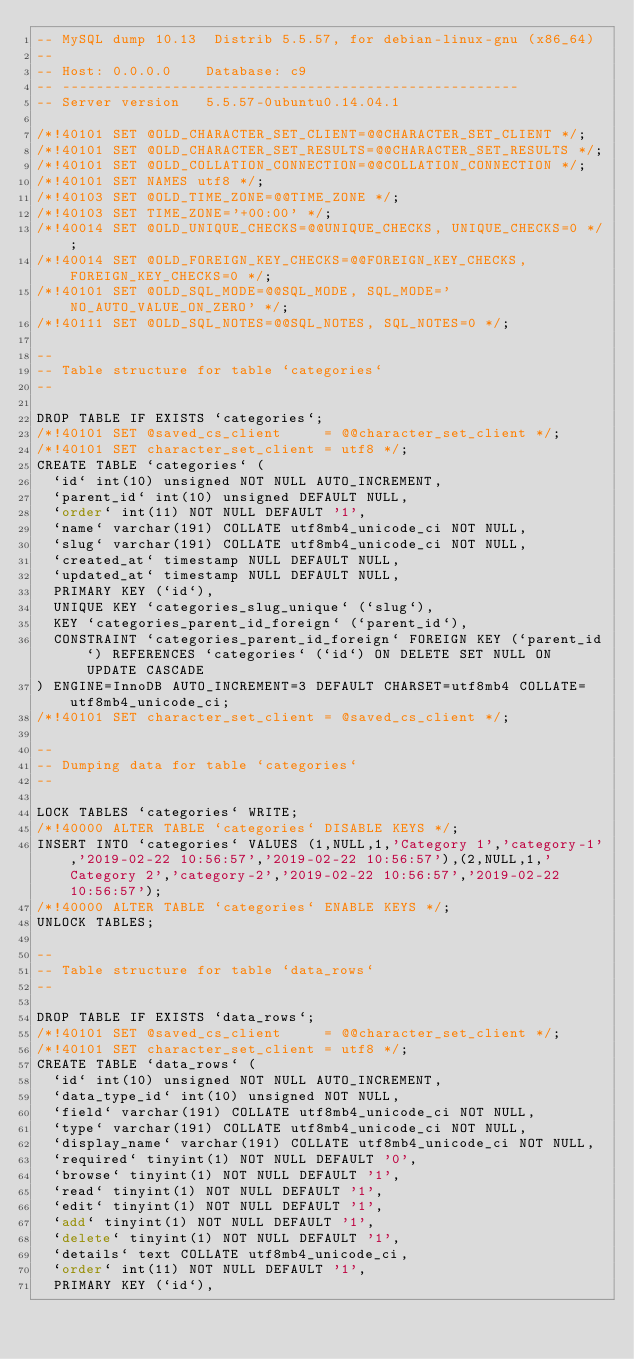Convert code to text. <code><loc_0><loc_0><loc_500><loc_500><_SQL_>-- MySQL dump 10.13  Distrib 5.5.57, for debian-linux-gnu (x86_64)
--
-- Host: 0.0.0.0    Database: c9
-- ------------------------------------------------------
-- Server version	5.5.57-0ubuntu0.14.04.1

/*!40101 SET @OLD_CHARACTER_SET_CLIENT=@@CHARACTER_SET_CLIENT */;
/*!40101 SET @OLD_CHARACTER_SET_RESULTS=@@CHARACTER_SET_RESULTS */;
/*!40101 SET @OLD_COLLATION_CONNECTION=@@COLLATION_CONNECTION */;
/*!40101 SET NAMES utf8 */;
/*!40103 SET @OLD_TIME_ZONE=@@TIME_ZONE */;
/*!40103 SET TIME_ZONE='+00:00' */;
/*!40014 SET @OLD_UNIQUE_CHECKS=@@UNIQUE_CHECKS, UNIQUE_CHECKS=0 */;
/*!40014 SET @OLD_FOREIGN_KEY_CHECKS=@@FOREIGN_KEY_CHECKS, FOREIGN_KEY_CHECKS=0 */;
/*!40101 SET @OLD_SQL_MODE=@@SQL_MODE, SQL_MODE='NO_AUTO_VALUE_ON_ZERO' */;
/*!40111 SET @OLD_SQL_NOTES=@@SQL_NOTES, SQL_NOTES=0 */;

--
-- Table structure for table `categories`
--

DROP TABLE IF EXISTS `categories`;
/*!40101 SET @saved_cs_client     = @@character_set_client */;
/*!40101 SET character_set_client = utf8 */;
CREATE TABLE `categories` (
  `id` int(10) unsigned NOT NULL AUTO_INCREMENT,
  `parent_id` int(10) unsigned DEFAULT NULL,
  `order` int(11) NOT NULL DEFAULT '1',
  `name` varchar(191) COLLATE utf8mb4_unicode_ci NOT NULL,
  `slug` varchar(191) COLLATE utf8mb4_unicode_ci NOT NULL,
  `created_at` timestamp NULL DEFAULT NULL,
  `updated_at` timestamp NULL DEFAULT NULL,
  PRIMARY KEY (`id`),
  UNIQUE KEY `categories_slug_unique` (`slug`),
  KEY `categories_parent_id_foreign` (`parent_id`),
  CONSTRAINT `categories_parent_id_foreign` FOREIGN KEY (`parent_id`) REFERENCES `categories` (`id`) ON DELETE SET NULL ON UPDATE CASCADE
) ENGINE=InnoDB AUTO_INCREMENT=3 DEFAULT CHARSET=utf8mb4 COLLATE=utf8mb4_unicode_ci;
/*!40101 SET character_set_client = @saved_cs_client */;

--
-- Dumping data for table `categories`
--

LOCK TABLES `categories` WRITE;
/*!40000 ALTER TABLE `categories` DISABLE KEYS */;
INSERT INTO `categories` VALUES (1,NULL,1,'Category 1','category-1','2019-02-22 10:56:57','2019-02-22 10:56:57'),(2,NULL,1,'Category 2','category-2','2019-02-22 10:56:57','2019-02-22 10:56:57');
/*!40000 ALTER TABLE `categories` ENABLE KEYS */;
UNLOCK TABLES;

--
-- Table structure for table `data_rows`
--

DROP TABLE IF EXISTS `data_rows`;
/*!40101 SET @saved_cs_client     = @@character_set_client */;
/*!40101 SET character_set_client = utf8 */;
CREATE TABLE `data_rows` (
  `id` int(10) unsigned NOT NULL AUTO_INCREMENT,
  `data_type_id` int(10) unsigned NOT NULL,
  `field` varchar(191) COLLATE utf8mb4_unicode_ci NOT NULL,
  `type` varchar(191) COLLATE utf8mb4_unicode_ci NOT NULL,
  `display_name` varchar(191) COLLATE utf8mb4_unicode_ci NOT NULL,
  `required` tinyint(1) NOT NULL DEFAULT '0',
  `browse` tinyint(1) NOT NULL DEFAULT '1',
  `read` tinyint(1) NOT NULL DEFAULT '1',
  `edit` tinyint(1) NOT NULL DEFAULT '1',
  `add` tinyint(1) NOT NULL DEFAULT '1',
  `delete` tinyint(1) NOT NULL DEFAULT '1',
  `details` text COLLATE utf8mb4_unicode_ci,
  `order` int(11) NOT NULL DEFAULT '1',
  PRIMARY KEY (`id`),</code> 